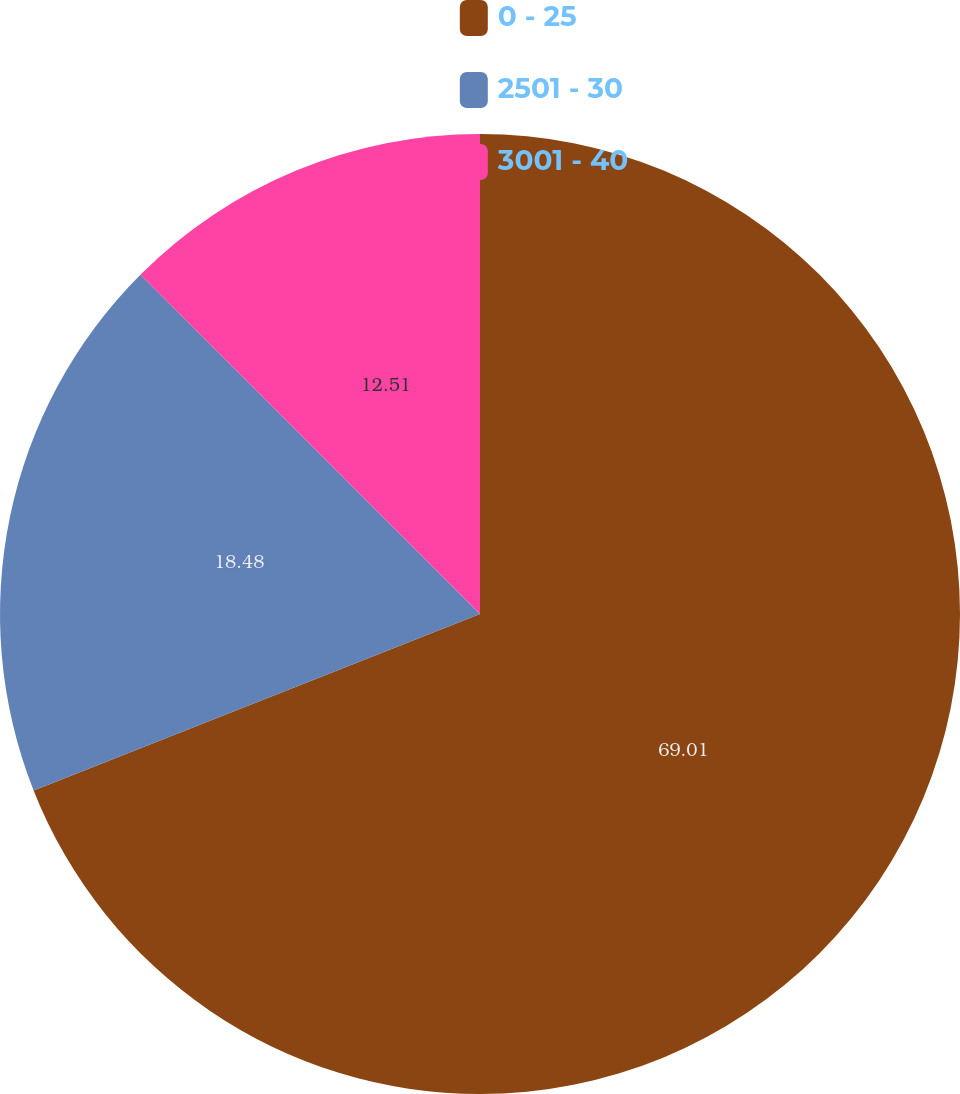<chart> <loc_0><loc_0><loc_500><loc_500><pie_chart><fcel>0 - 25<fcel>2501 - 30<fcel>3001 - 40<nl><fcel>69.01%<fcel>18.48%<fcel>12.51%<nl></chart> 